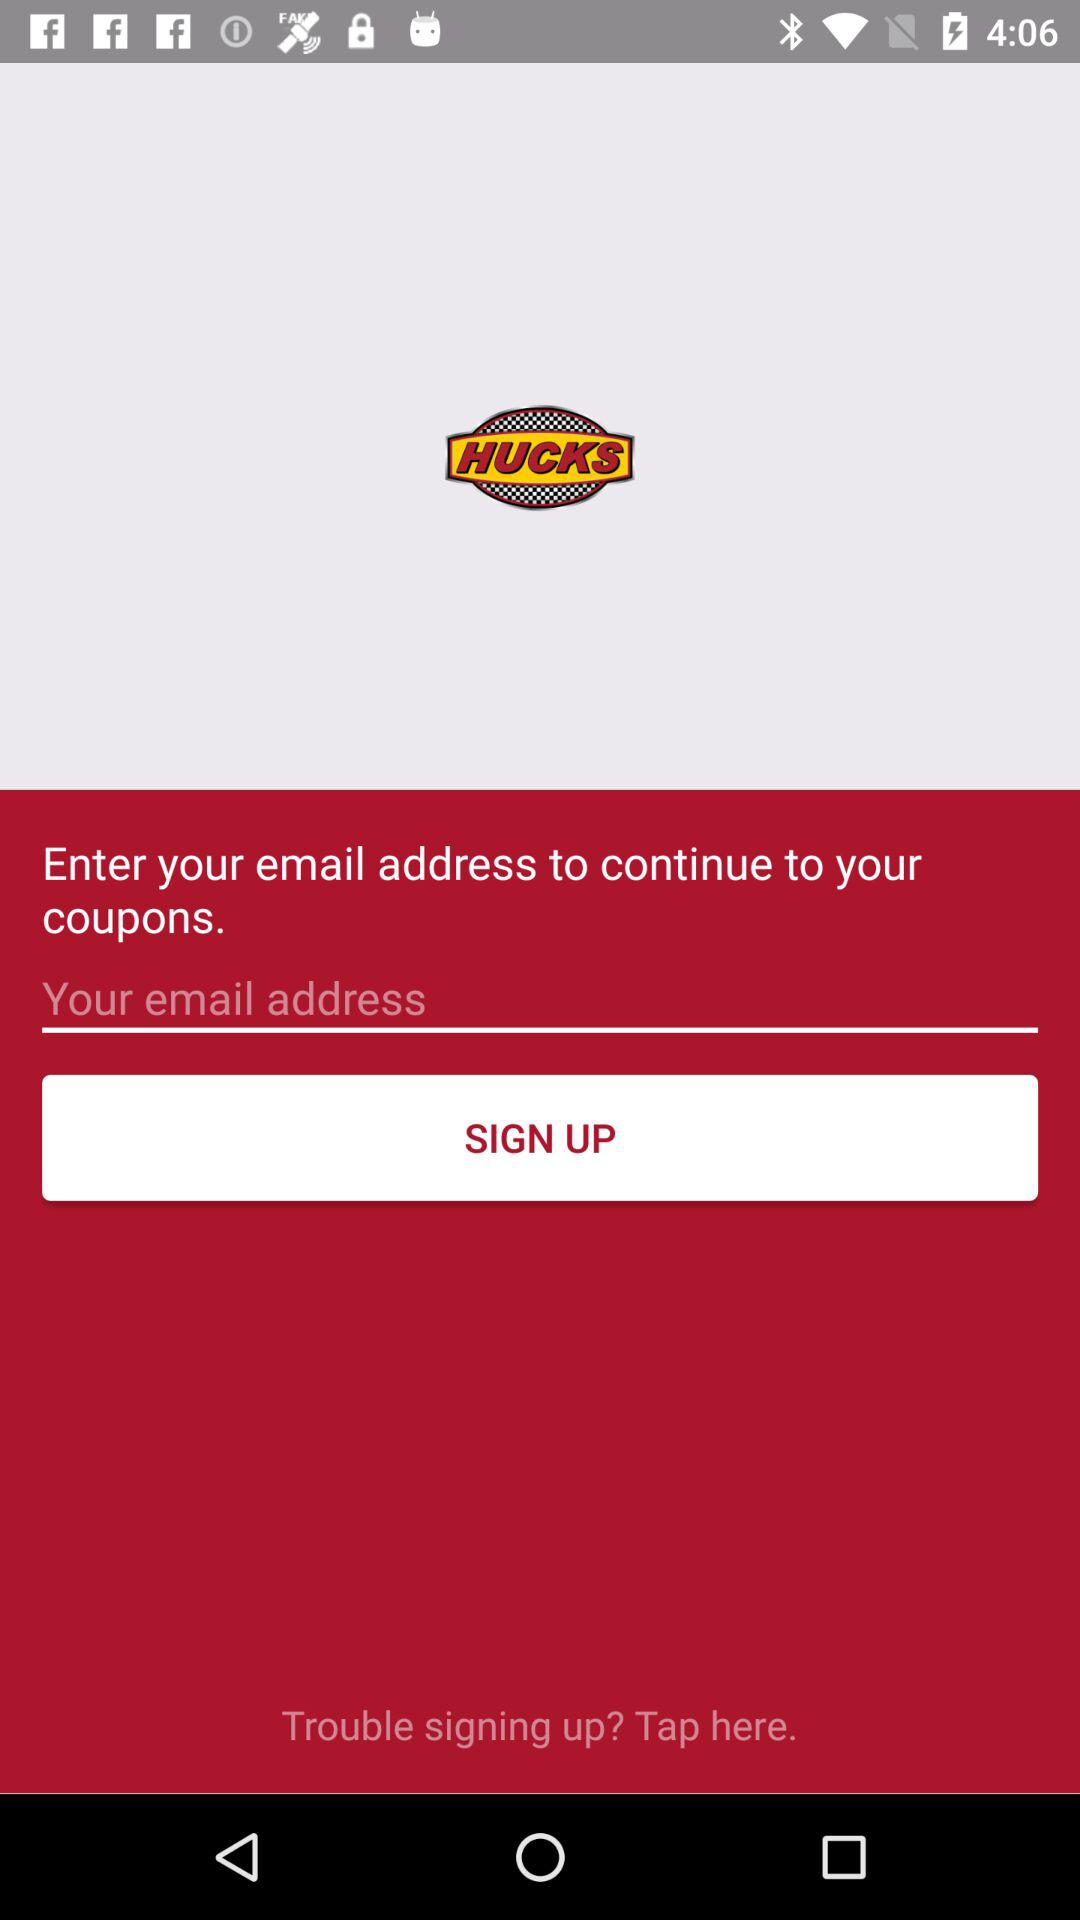What is the name of the application? The name of the application is "HUCKS". 